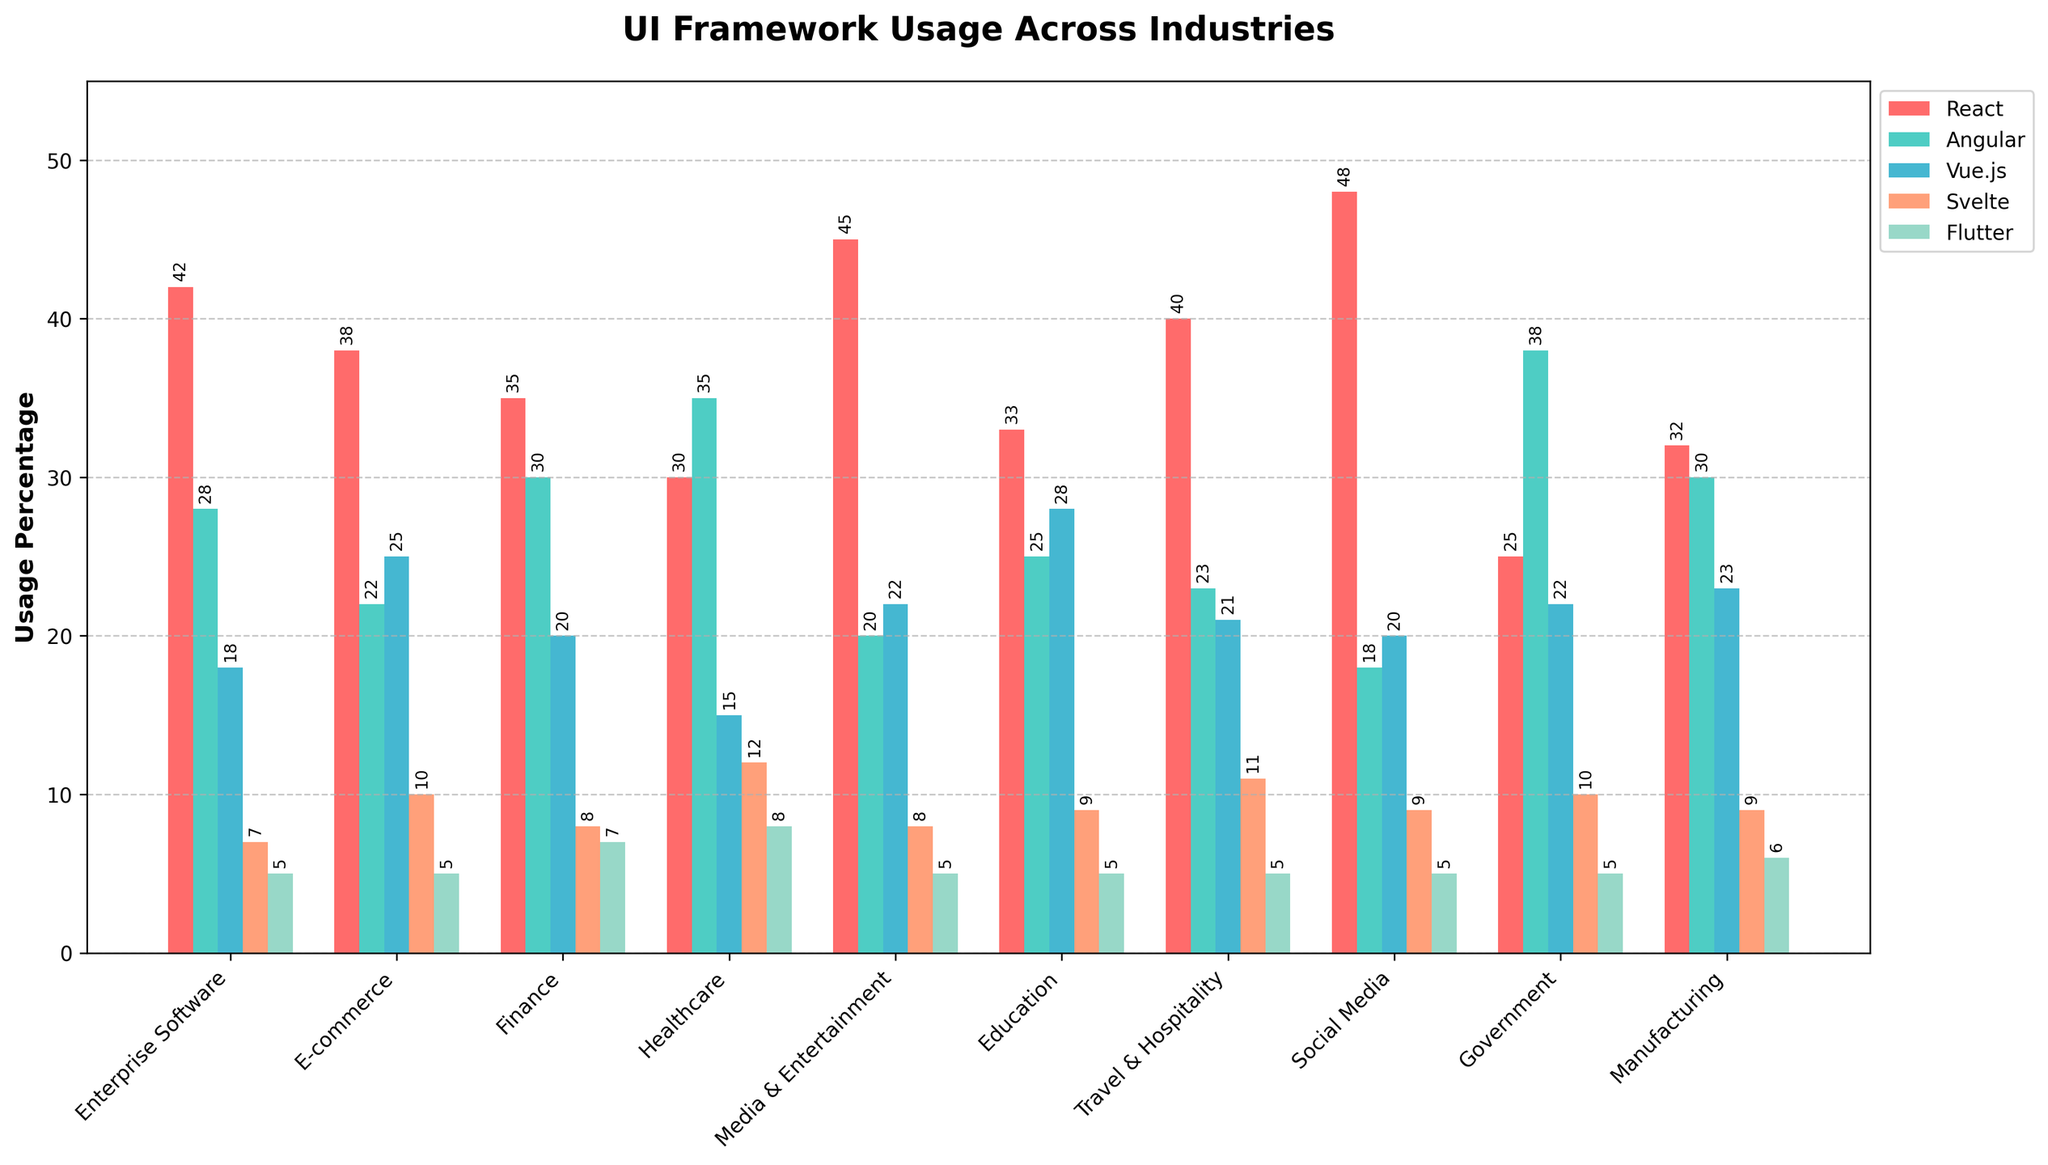Which industry has the highest usage percentage of React? By examining the bar heights for React across different industries, the highest bar corresponds to Social Media.
Answer: Social Media In which industry is Angular more popular than React? Compare the heights of the Angular and React bars for each industry; Government shows Angular's bar higher than React's.
Answer: Government What is the combined usage percentage of Vue.js in Finance and Healthcare? Sum the usage percentages of Vue.js in Finance (20) and Healthcare (15), resulting in 20 + 15 = 35.
Answer: 35 Which industry has the smallest usage percentage of Svelte? By comparing the bar heights for Svelte across all industries, Enterprise Software has the smallest bar.
Answer: Enterprise Software Which two industries have the same usage percentage for Flutter? By looking at the bar heights for Flutter and comparing their values, it is evident that multiple industries have a usage percentage of 5 including Enterprise Software, E-commerce, Media & Entertainment, Education, Travel & Hospitality, and Social Media.
Answer: Enterprise Software, E-commerce, Media & Entertainment, Education, Travel & Hospitality, Social Media What is the average usage percentage of React across all industries? Sum the usage percentages of React across all industries ((42+38+35+30+45+33+40+48+25+32)=368) and divide by the number of industries (10), i.e., 368/10 = 36.8.
Answer: 36.8 Is the usage percentage of Angular in Finance higher than in Manufacturing? Compare the Angular usage percentages in Finance (30) and Manufacturing (30); they are the same.
Answer: No, they are the same Which framework is used the most in Media & Entertainment? Compare the bar heights of all frameworks in Media & Entertainment, React has the highest bar.
Answer: React Which industry has the widest variety in the usage of different frameworks? By comparing the range (difference between the highest and lowest values) of bar heights for each industry, Healthcare has a range from 35 (Angular) to 8 (Flutter), indicating the widest variety.
Answer: Healthcare What is the difference in usage percentage of Vue.js between E-commerce and Travel & Hospitality industries? Calculate the difference by subtracting the Vue.js percentage in Travel & Hospitality (21) from that in E-commerce (25), i.e., 25 - 21 = 4.
Answer: 4 